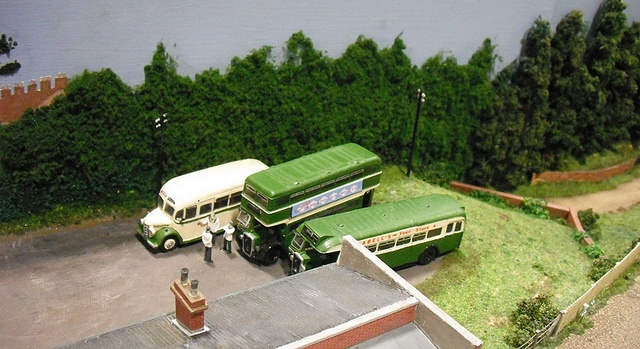Describe the objects in this image and their specific colors. I can see bus in gray, black, lightgreen, darkgreen, and olive tones, bus in gray, lightgreen, black, and darkgreen tones, bus in gray, ivory, tan, black, and darkgreen tones, people in gray, ivory, black, and darkgray tones, and people in gray, ivory, black, and darkgray tones in this image. 